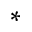Convert formula to latex. <formula><loc_0><loc_0><loc_500><loc_500>^ { \ast }</formula> 